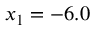<formula> <loc_0><loc_0><loc_500><loc_500>x _ { 1 } = - 6 . 0</formula> 